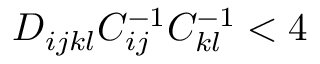<formula> <loc_0><loc_0><loc_500><loc_500>D _ { i j k l } C _ { i j } ^ { - 1 } C _ { k l } ^ { - 1 } < 4</formula> 